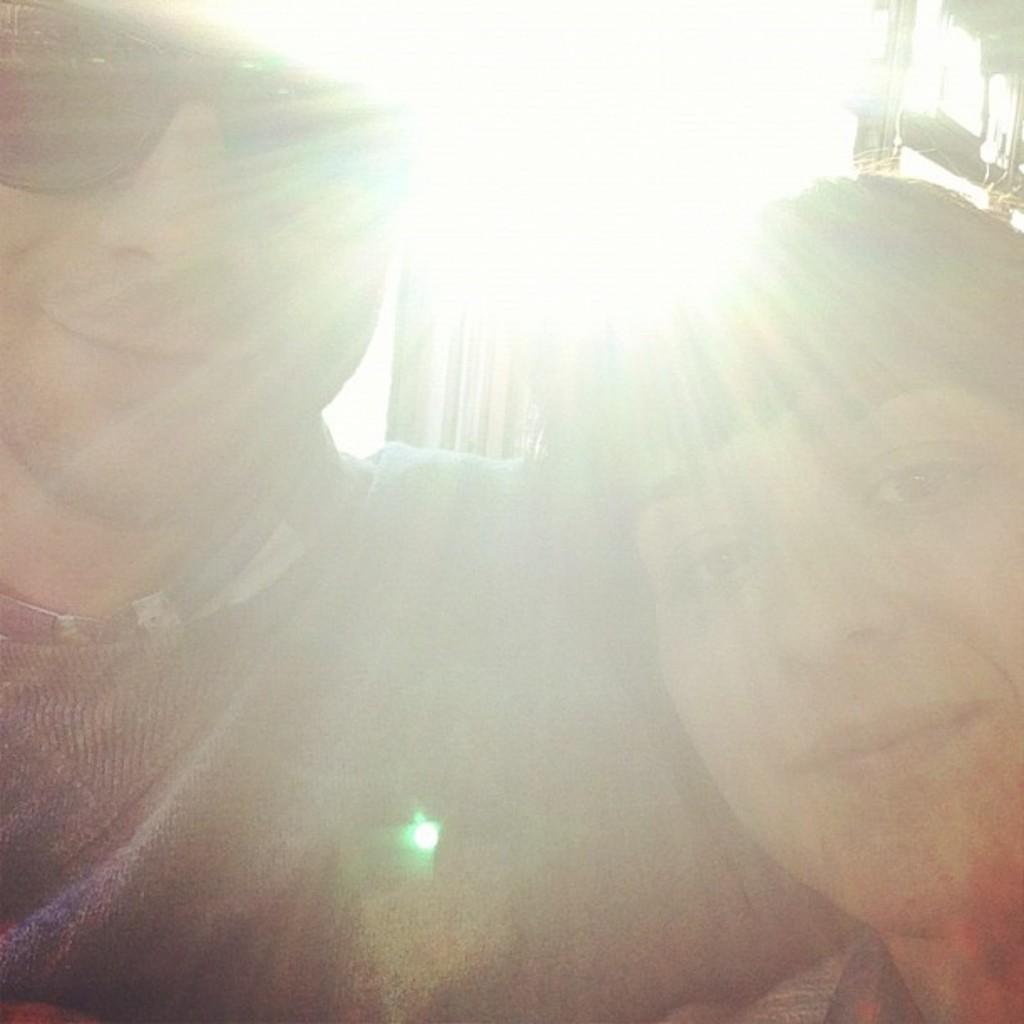Can you describe this image briefly? As we can see in the image in the front there are two people and light. 